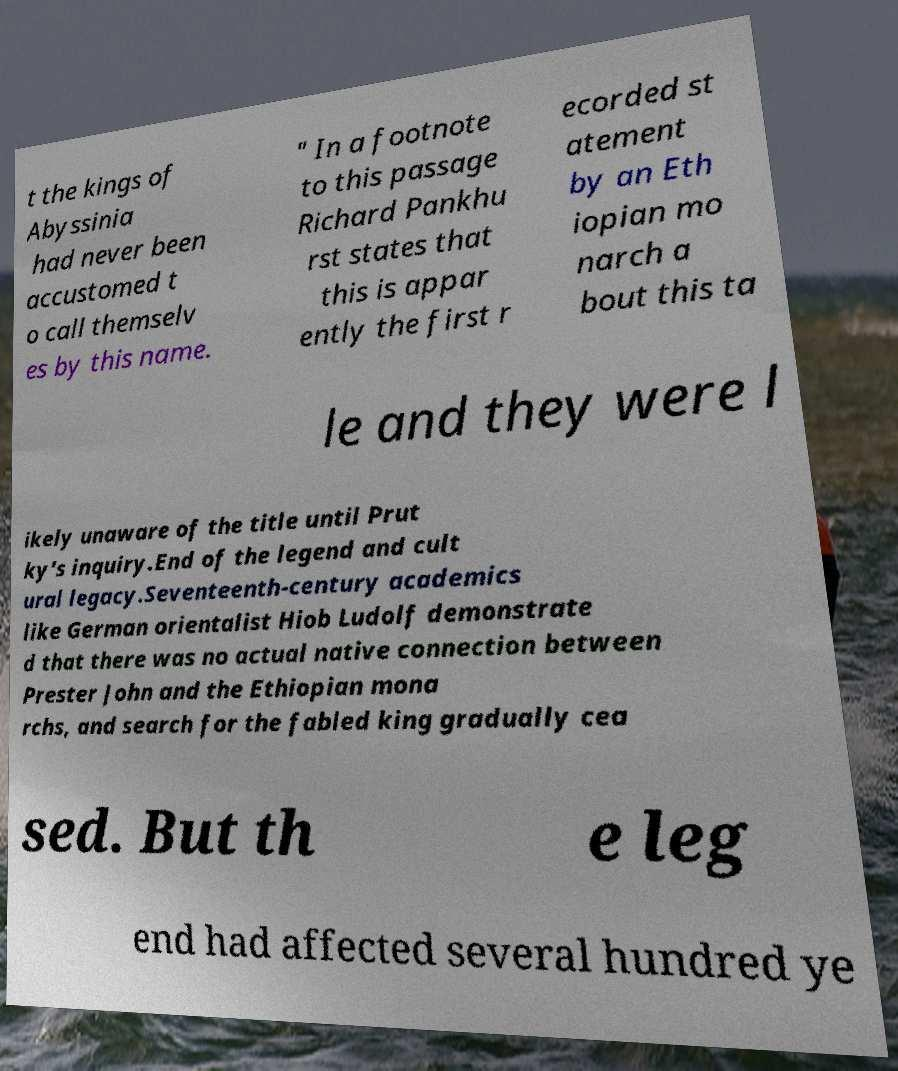Can you read and provide the text displayed in the image?This photo seems to have some interesting text. Can you extract and type it out for me? t the kings of Abyssinia had never been accustomed t o call themselv es by this name. " In a footnote to this passage Richard Pankhu rst states that this is appar ently the first r ecorded st atement by an Eth iopian mo narch a bout this ta le and they were l ikely unaware of the title until Prut ky's inquiry.End of the legend and cult ural legacy.Seventeenth-century academics like German orientalist Hiob Ludolf demonstrate d that there was no actual native connection between Prester John and the Ethiopian mona rchs, and search for the fabled king gradually cea sed. But th e leg end had affected several hundred ye 